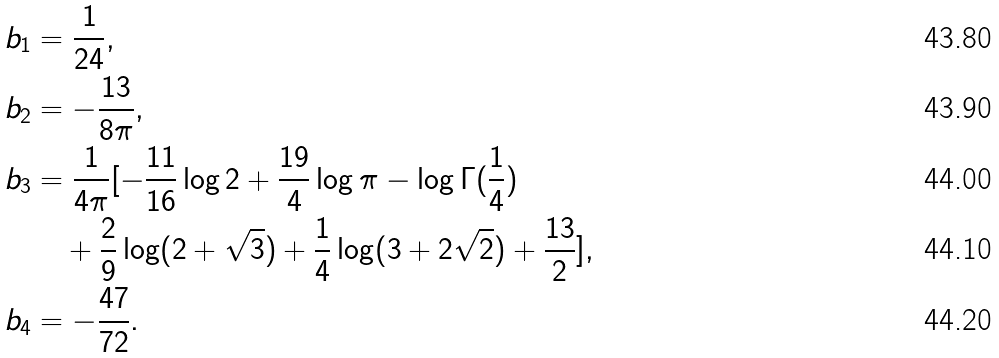Convert formula to latex. <formula><loc_0><loc_0><loc_500><loc_500>b _ { 1 } & = \frac { 1 } { 2 4 } , \\ b _ { 2 } & = - \frac { 1 3 } { 8 \pi } , \\ b _ { 3 } & = \frac { 1 } { 4 \pi } [ - \frac { 1 1 } { 1 6 } \log 2 + \frac { 1 9 } { 4 } \log \pi - \log \Gamma ( \frac { 1 } { 4 } ) \\ & \quad + \frac { 2 } { 9 } \log ( 2 + \sqrt { 3 } ) + \frac { 1 } { 4 } \log ( 3 + 2 \sqrt { 2 } ) + \frac { 1 3 } { 2 } ] , \\ b _ { 4 } & = - \frac { 4 7 } { 7 2 } .</formula> 